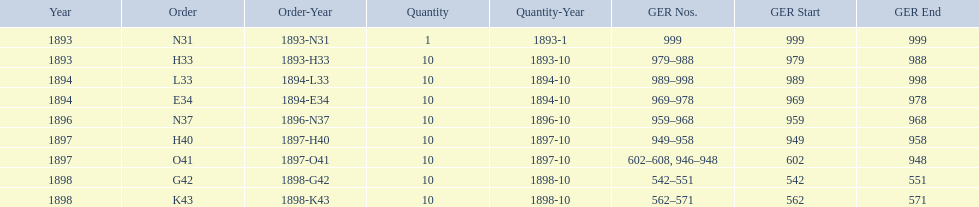What is the last year listed? 1898. 